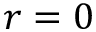<formula> <loc_0><loc_0><loc_500><loc_500>r = 0</formula> 